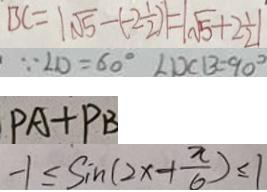Convert formula to latex. <formula><loc_0><loc_0><loc_500><loc_500>B C = \vert \sqrt { 5 } - ( - 2 \frac { 1 } { 2 } ) \vert = \vert \sqrt { 5 } + 2 \frac { 1 } { 2 } \vert 
 \because \angle D = 6 0 ^ { \circ } \angle D C B = 9 0 ^ { \circ } 
 P A + P B 
 - 1 \leq \sin ( 2 x + \frac { \pi } { 6 } ) \leq 1</formula> 